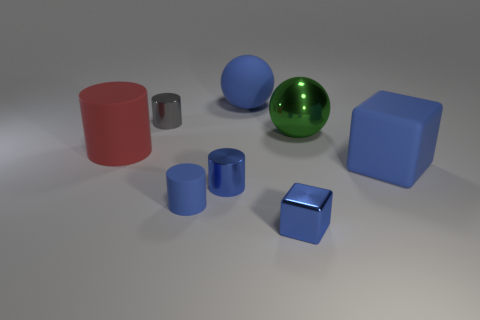Add 1 cyan metallic objects. How many objects exist? 9 Subtract all small cylinders. How many cylinders are left? 1 Subtract all blue cylinders. How many cylinders are left? 2 Subtract 1 cubes. How many cubes are left? 1 Add 1 gray metallic cylinders. How many gray metallic cylinders are left? 2 Add 8 small blue metal things. How many small blue metal things exist? 10 Subtract 0 purple cubes. How many objects are left? 8 Subtract all cubes. How many objects are left? 6 Subtract all yellow blocks. Subtract all brown cylinders. How many blocks are left? 2 Subtract all blue cylinders. How many red spheres are left? 0 